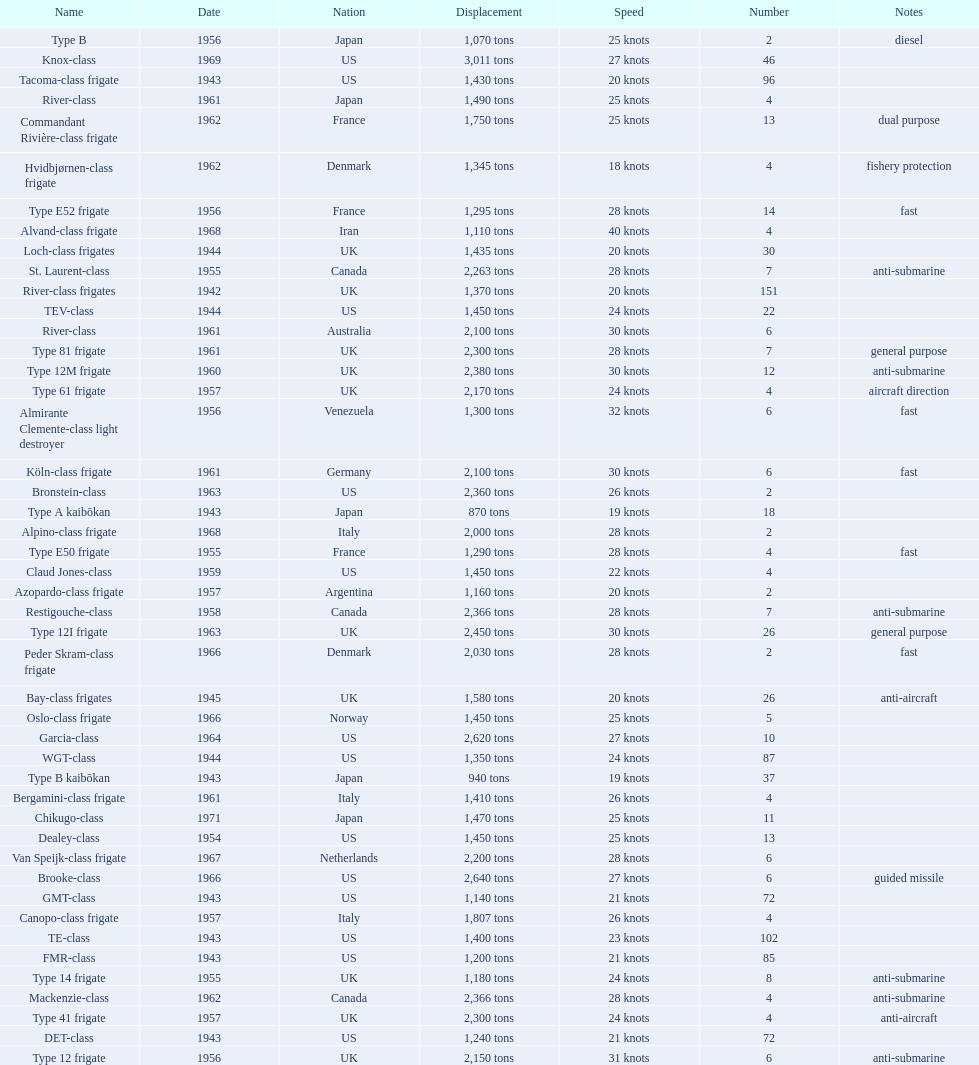What is the top speed? 40 knots. 